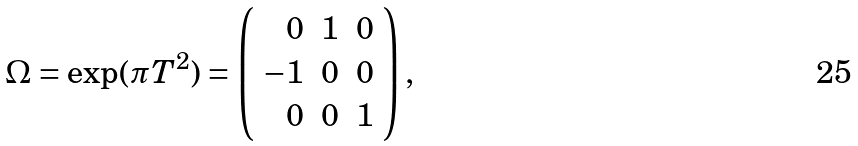<formula> <loc_0><loc_0><loc_500><loc_500>\Omega = \exp ( \pi T ^ { 2 } ) = \left ( \begin{array} { r r r } 0 & 1 & 0 \\ - 1 & 0 & 0 \\ 0 & 0 & 1 \end{array} \right ) ,</formula> 